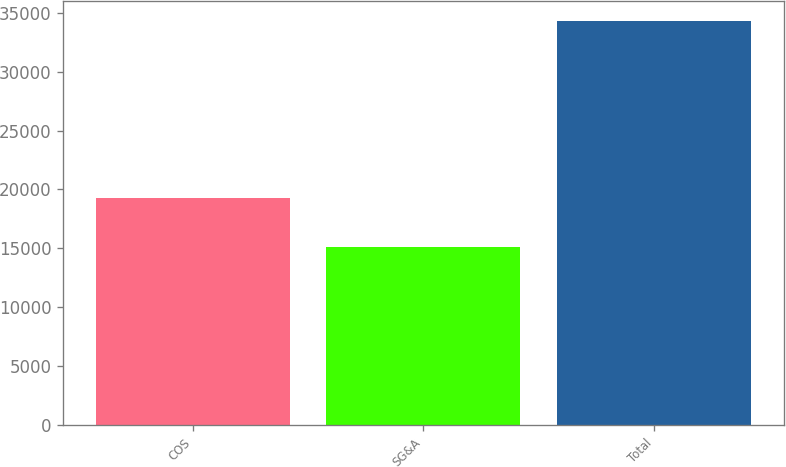Convert chart. <chart><loc_0><loc_0><loc_500><loc_500><bar_chart><fcel>COS<fcel>SG&A<fcel>Total<nl><fcel>19264<fcel>15086<fcel>34350<nl></chart> 